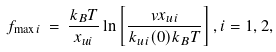<formula> <loc_0><loc_0><loc_500><loc_500>f _ { \max i } \, = \, \frac { k _ { B } T } { x _ { u i } } \ln \left [ \frac { v x _ { u i } } { k _ { u i } ( 0 ) k _ { B } T } \right ] , i = 1 , 2 ,</formula> 